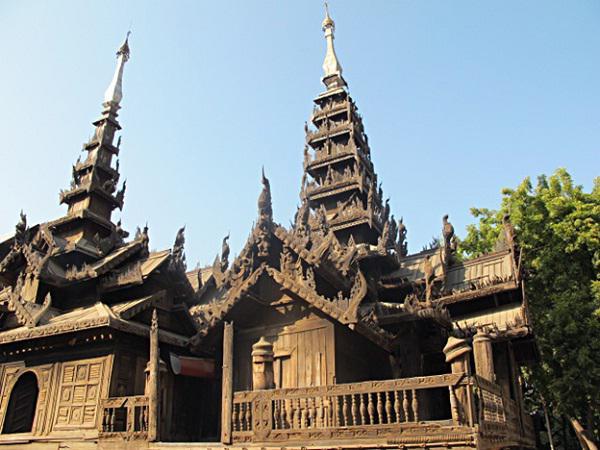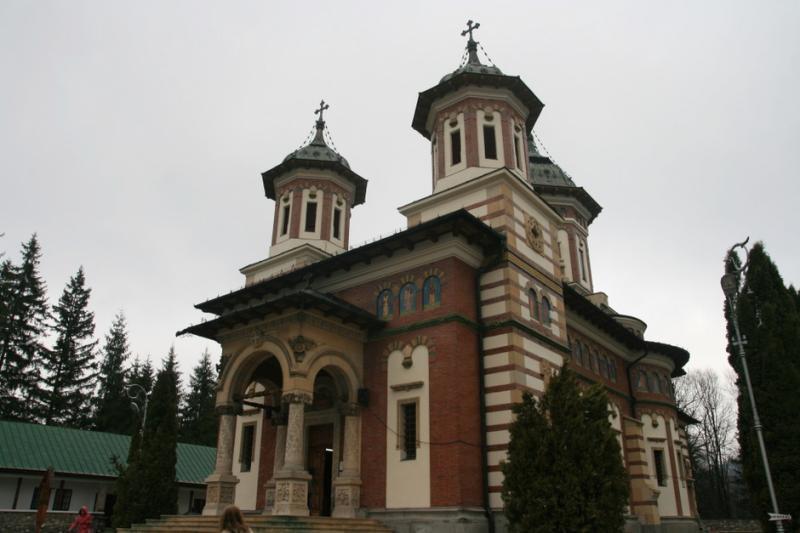The first image is the image on the left, the second image is the image on the right. Evaluate the accuracy of this statement regarding the images: "There are two crosses on the building in at least one of the images.". Is it true? Answer yes or no. Yes. The first image is the image on the left, the second image is the image on the right. Assess this claim about the two images: "An image shows a mottled gray building with a cone-shaped roof that has something growing on it.". Correct or not? Answer yes or no. No. 